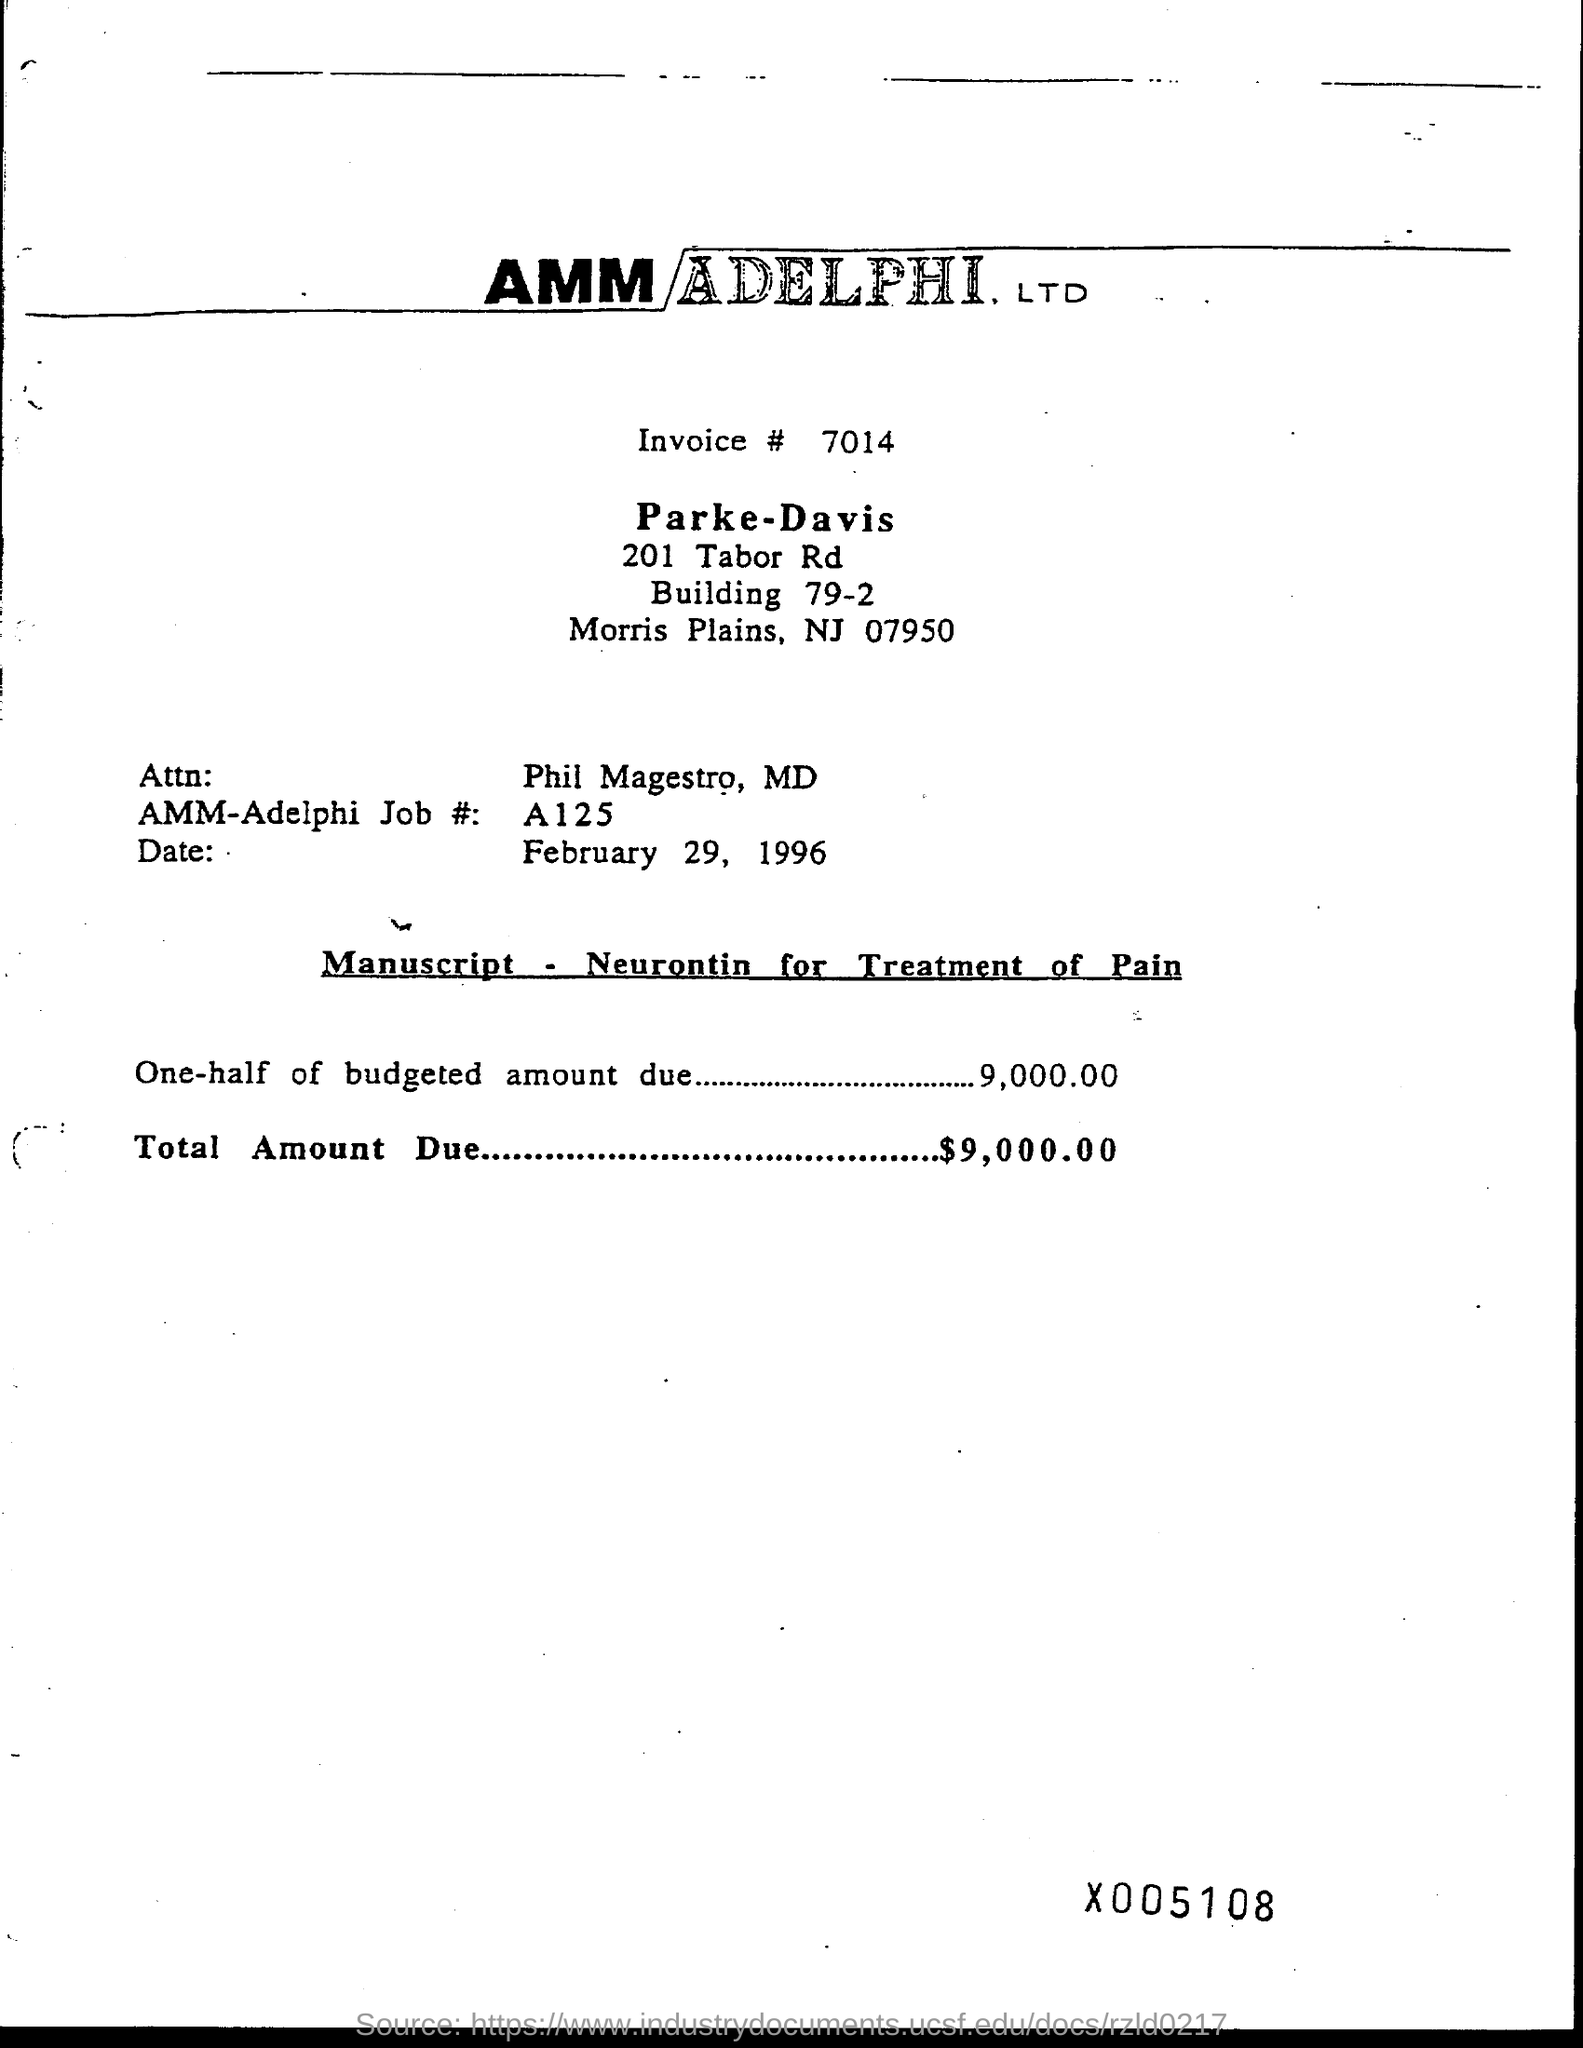Mention a couple of crucial points in this snapshot. The date mentioned in the above manuscript is February 29, 1996. The name of Attn is Phil Magestro, M.D. Please provide the invoice number, which is 7014... The total amount due is $9,000.00. 